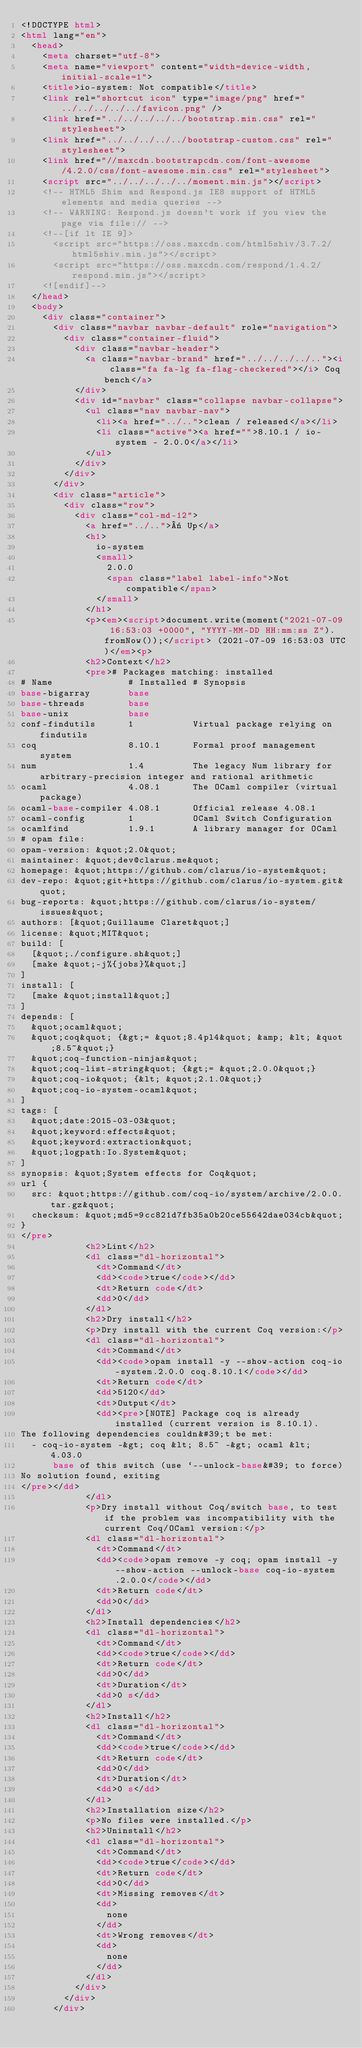<code> <loc_0><loc_0><loc_500><loc_500><_HTML_><!DOCTYPE html>
<html lang="en">
  <head>
    <meta charset="utf-8">
    <meta name="viewport" content="width=device-width, initial-scale=1">
    <title>io-system: Not compatible</title>
    <link rel="shortcut icon" type="image/png" href="../../../../../favicon.png" />
    <link href="../../../../../bootstrap.min.css" rel="stylesheet">
    <link href="../../../../../bootstrap-custom.css" rel="stylesheet">
    <link href="//maxcdn.bootstrapcdn.com/font-awesome/4.2.0/css/font-awesome.min.css" rel="stylesheet">
    <script src="../../../../../moment.min.js"></script>
    <!-- HTML5 Shim and Respond.js IE8 support of HTML5 elements and media queries -->
    <!-- WARNING: Respond.js doesn't work if you view the page via file:// -->
    <!--[if lt IE 9]>
      <script src="https://oss.maxcdn.com/html5shiv/3.7.2/html5shiv.min.js"></script>
      <script src="https://oss.maxcdn.com/respond/1.4.2/respond.min.js"></script>
    <![endif]-->
  </head>
  <body>
    <div class="container">
      <div class="navbar navbar-default" role="navigation">
        <div class="container-fluid">
          <div class="navbar-header">
            <a class="navbar-brand" href="../../../../.."><i class="fa fa-lg fa-flag-checkered"></i> Coq bench</a>
          </div>
          <div id="navbar" class="collapse navbar-collapse">
            <ul class="nav navbar-nav">
              <li><a href="../..">clean / released</a></li>
              <li class="active"><a href="">8.10.1 / io-system - 2.0.0</a></li>
            </ul>
          </div>
        </div>
      </div>
      <div class="article">
        <div class="row">
          <div class="col-md-12">
            <a href="../..">« Up</a>
            <h1>
              io-system
              <small>
                2.0.0
                <span class="label label-info">Not compatible</span>
              </small>
            </h1>
            <p><em><script>document.write(moment("2021-07-09 16:53:03 +0000", "YYYY-MM-DD HH:mm:ss Z").fromNow());</script> (2021-07-09 16:53:03 UTC)</em><p>
            <h2>Context</h2>
            <pre># Packages matching: installed
# Name              # Installed # Synopsis
base-bigarray       base
base-threads        base
base-unix           base
conf-findutils      1           Virtual package relying on findutils
coq                 8.10.1      Formal proof management system
num                 1.4         The legacy Num library for arbitrary-precision integer and rational arithmetic
ocaml               4.08.1      The OCaml compiler (virtual package)
ocaml-base-compiler 4.08.1      Official release 4.08.1
ocaml-config        1           OCaml Switch Configuration
ocamlfind           1.9.1       A library manager for OCaml
# opam file:
opam-version: &quot;2.0&quot;
maintainer: &quot;dev@clarus.me&quot;
homepage: &quot;https://github.com/clarus/io-system&quot;
dev-repo: &quot;git+https://github.com/clarus/io-system.git&quot;
bug-reports: &quot;https://github.com/clarus/io-system/issues&quot;
authors: [&quot;Guillaume Claret&quot;]
license: &quot;MIT&quot;
build: [
  [&quot;./configure.sh&quot;]
  [make &quot;-j%{jobs}%&quot;]
]
install: [
  [make &quot;install&quot;]
]
depends: [
  &quot;ocaml&quot;
  &quot;coq&quot; {&gt;= &quot;8.4pl4&quot; &amp; &lt; &quot;8.5~&quot;}
  &quot;coq-function-ninjas&quot;
  &quot;coq-list-string&quot; {&gt;= &quot;2.0.0&quot;}
  &quot;coq-io&quot; {&lt; &quot;2.1.0&quot;}
  &quot;coq-io-system-ocaml&quot;
]
tags: [
  &quot;date:2015-03-03&quot;
  &quot;keyword:effects&quot;
  &quot;keyword:extraction&quot;
  &quot;logpath:Io.System&quot;
]
synopsis: &quot;System effects for Coq&quot;
url {
  src: &quot;https://github.com/coq-io/system/archive/2.0.0.tar.gz&quot;
  checksum: &quot;md5=9cc821d7fb35a0b20ce55642dae034cb&quot;
}
</pre>
            <h2>Lint</h2>
            <dl class="dl-horizontal">
              <dt>Command</dt>
              <dd><code>true</code></dd>
              <dt>Return code</dt>
              <dd>0</dd>
            </dl>
            <h2>Dry install</h2>
            <p>Dry install with the current Coq version:</p>
            <dl class="dl-horizontal">
              <dt>Command</dt>
              <dd><code>opam install -y --show-action coq-io-system.2.0.0 coq.8.10.1</code></dd>
              <dt>Return code</dt>
              <dd>5120</dd>
              <dt>Output</dt>
              <dd><pre>[NOTE] Package coq is already installed (current version is 8.10.1).
The following dependencies couldn&#39;t be met:
  - coq-io-system -&gt; coq &lt; 8.5~ -&gt; ocaml &lt; 4.03.0
      base of this switch (use `--unlock-base&#39; to force)
No solution found, exiting
</pre></dd>
            </dl>
            <p>Dry install without Coq/switch base, to test if the problem was incompatibility with the current Coq/OCaml version:</p>
            <dl class="dl-horizontal">
              <dt>Command</dt>
              <dd><code>opam remove -y coq; opam install -y --show-action --unlock-base coq-io-system.2.0.0</code></dd>
              <dt>Return code</dt>
              <dd>0</dd>
            </dl>
            <h2>Install dependencies</h2>
            <dl class="dl-horizontal">
              <dt>Command</dt>
              <dd><code>true</code></dd>
              <dt>Return code</dt>
              <dd>0</dd>
              <dt>Duration</dt>
              <dd>0 s</dd>
            </dl>
            <h2>Install</h2>
            <dl class="dl-horizontal">
              <dt>Command</dt>
              <dd><code>true</code></dd>
              <dt>Return code</dt>
              <dd>0</dd>
              <dt>Duration</dt>
              <dd>0 s</dd>
            </dl>
            <h2>Installation size</h2>
            <p>No files were installed.</p>
            <h2>Uninstall</h2>
            <dl class="dl-horizontal">
              <dt>Command</dt>
              <dd><code>true</code></dd>
              <dt>Return code</dt>
              <dd>0</dd>
              <dt>Missing removes</dt>
              <dd>
                none
              </dd>
              <dt>Wrong removes</dt>
              <dd>
                none
              </dd>
            </dl>
          </div>
        </div>
      </div></code> 